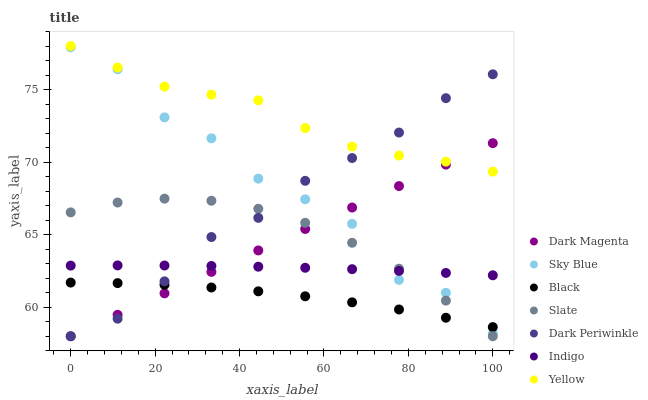Does Black have the minimum area under the curve?
Answer yes or no. Yes. Does Yellow have the maximum area under the curve?
Answer yes or no. Yes. Does Dark Magenta have the minimum area under the curve?
Answer yes or no. No. Does Dark Magenta have the maximum area under the curve?
Answer yes or no. No. Is Dark Magenta the smoothest?
Answer yes or no. Yes. Is Sky Blue the roughest?
Answer yes or no. Yes. Is Slate the smoothest?
Answer yes or no. No. Is Slate the roughest?
Answer yes or no. No. Does Dark Magenta have the lowest value?
Answer yes or no. Yes. Does Yellow have the lowest value?
Answer yes or no. No. Does Yellow have the highest value?
Answer yes or no. Yes. Does Dark Magenta have the highest value?
Answer yes or no. No. Is Sky Blue less than Yellow?
Answer yes or no. Yes. Is Yellow greater than Sky Blue?
Answer yes or no. Yes. Does Dark Periwinkle intersect Sky Blue?
Answer yes or no. Yes. Is Dark Periwinkle less than Sky Blue?
Answer yes or no. No. Is Dark Periwinkle greater than Sky Blue?
Answer yes or no. No. Does Sky Blue intersect Yellow?
Answer yes or no. No. 